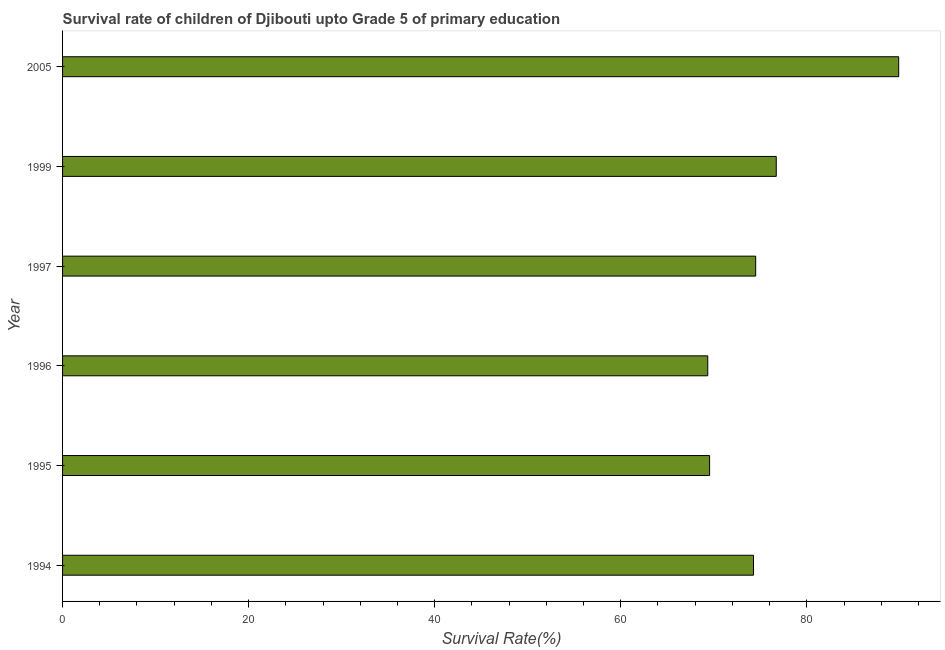Does the graph contain any zero values?
Your answer should be compact. No. Does the graph contain grids?
Ensure brevity in your answer.  No. What is the title of the graph?
Provide a succinct answer. Survival rate of children of Djibouti upto Grade 5 of primary education. What is the label or title of the X-axis?
Offer a terse response. Survival Rate(%). What is the label or title of the Y-axis?
Your response must be concise. Year. What is the survival rate in 1996?
Give a very brief answer. 69.35. Across all years, what is the maximum survival rate?
Your response must be concise. 89.87. Across all years, what is the minimum survival rate?
Your response must be concise. 69.35. What is the sum of the survival rate?
Make the answer very short. 454.25. What is the difference between the survival rate in 1994 and 1999?
Your answer should be compact. -2.45. What is the average survival rate per year?
Your answer should be very brief. 75.71. What is the median survival rate?
Keep it short and to the point. 74.38. Do a majority of the years between 1995 and 1996 (inclusive) have survival rate greater than 56 %?
Your answer should be very brief. Yes. What is the ratio of the survival rate in 1994 to that in 2005?
Offer a terse response. 0.83. Is the survival rate in 1994 less than that in 1997?
Your response must be concise. Yes. Is the difference between the survival rate in 1994 and 1997 greater than the difference between any two years?
Your response must be concise. No. What is the difference between the highest and the second highest survival rate?
Make the answer very short. 13.16. Is the sum of the survival rate in 1995 and 1997 greater than the maximum survival rate across all years?
Make the answer very short. Yes. What is the difference between the highest and the lowest survival rate?
Offer a terse response. 20.52. In how many years, is the survival rate greater than the average survival rate taken over all years?
Give a very brief answer. 2. How many bars are there?
Your answer should be compact. 6. Are all the bars in the graph horizontal?
Provide a short and direct response. Yes. How many years are there in the graph?
Your answer should be very brief. 6. What is the difference between two consecutive major ticks on the X-axis?
Offer a terse response. 20. What is the Survival Rate(%) in 1994?
Give a very brief answer. 74.27. What is the Survival Rate(%) in 1995?
Offer a very short reply. 69.55. What is the Survival Rate(%) of 1996?
Provide a succinct answer. 69.35. What is the Survival Rate(%) in 1997?
Offer a terse response. 74.5. What is the Survival Rate(%) of 1999?
Offer a terse response. 76.71. What is the Survival Rate(%) of 2005?
Ensure brevity in your answer.  89.87. What is the difference between the Survival Rate(%) in 1994 and 1995?
Make the answer very short. 4.72. What is the difference between the Survival Rate(%) in 1994 and 1996?
Ensure brevity in your answer.  4.92. What is the difference between the Survival Rate(%) in 1994 and 1997?
Make the answer very short. -0.24. What is the difference between the Survival Rate(%) in 1994 and 1999?
Offer a terse response. -2.45. What is the difference between the Survival Rate(%) in 1994 and 2005?
Your answer should be very brief. -15.61. What is the difference between the Survival Rate(%) in 1995 and 1996?
Keep it short and to the point. 0.2. What is the difference between the Survival Rate(%) in 1995 and 1997?
Provide a succinct answer. -4.95. What is the difference between the Survival Rate(%) in 1995 and 1999?
Provide a short and direct response. -7.16. What is the difference between the Survival Rate(%) in 1995 and 2005?
Make the answer very short. -20.32. What is the difference between the Survival Rate(%) in 1996 and 1997?
Your answer should be very brief. -5.15. What is the difference between the Survival Rate(%) in 1996 and 1999?
Keep it short and to the point. -7.36. What is the difference between the Survival Rate(%) in 1996 and 2005?
Your answer should be very brief. -20.52. What is the difference between the Survival Rate(%) in 1997 and 1999?
Your answer should be very brief. -2.21. What is the difference between the Survival Rate(%) in 1997 and 2005?
Make the answer very short. -15.37. What is the difference between the Survival Rate(%) in 1999 and 2005?
Your answer should be very brief. -13.16. What is the ratio of the Survival Rate(%) in 1994 to that in 1995?
Offer a very short reply. 1.07. What is the ratio of the Survival Rate(%) in 1994 to that in 1996?
Offer a terse response. 1.07. What is the ratio of the Survival Rate(%) in 1994 to that in 1999?
Offer a very short reply. 0.97. What is the ratio of the Survival Rate(%) in 1994 to that in 2005?
Provide a short and direct response. 0.83. What is the ratio of the Survival Rate(%) in 1995 to that in 1996?
Offer a terse response. 1. What is the ratio of the Survival Rate(%) in 1995 to that in 1997?
Keep it short and to the point. 0.93. What is the ratio of the Survival Rate(%) in 1995 to that in 1999?
Give a very brief answer. 0.91. What is the ratio of the Survival Rate(%) in 1995 to that in 2005?
Your response must be concise. 0.77. What is the ratio of the Survival Rate(%) in 1996 to that in 1997?
Your response must be concise. 0.93. What is the ratio of the Survival Rate(%) in 1996 to that in 1999?
Make the answer very short. 0.9. What is the ratio of the Survival Rate(%) in 1996 to that in 2005?
Your answer should be very brief. 0.77. What is the ratio of the Survival Rate(%) in 1997 to that in 2005?
Give a very brief answer. 0.83. What is the ratio of the Survival Rate(%) in 1999 to that in 2005?
Your answer should be very brief. 0.85. 